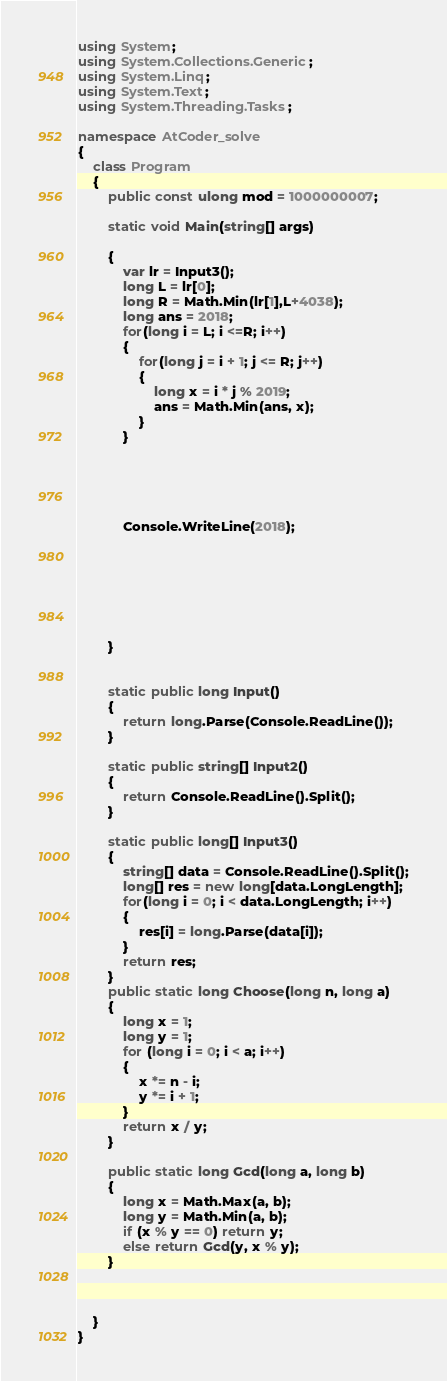Convert code to text. <code><loc_0><loc_0><loc_500><loc_500><_C#_>using System;
using System.Collections.Generic;
using System.Linq;
using System.Text;
using System.Threading.Tasks;

namespace AtCoder_solve
{
    class Program
    {
        public const ulong mod = 1000000007;

        static void Main(string[] args)

        {
            var lr = Input3();
            long L = lr[0];
            long R = Math.Min(lr[1],L+4038);
            long ans = 2018;
            for(long i = L; i <=R; i++)
            {
                for(long j = i + 1; j <= R; j++)
                {
                    long x = i * j % 2019;
                    ans = Math.Min(ans, x);
                }
            }
            
            

           
            
            Console.WriteLine(2018);
                
                





        }

       
        static public long Input()
        {
            return long.Parse(Console.ReadLine());
        }

        static public string[] Input2()
        {
            return Console.ReadLine().Split();
        }

        static public long[] Input3()
        {
            string[] data = Console.ReadLine().Split();
            long[] res = new long[data.LongLength];
            for(long i = 0; i < data.LongLength; i++)
            {
                res[i] = long.Parse(data[i]);
            }
            return res;
        }
        public static long Choose(long n, long a)
        {
            long x = 1;
            long y = 1;
            for (long i = 0; i < a; i++)
            {
                x *= n - i;
                y *= i + 1;
            }
            return x / y;
        }

        public static long Gcd(long a, long b)
        {
            long x = Math.Max(a, b);
            long y = Math.Min(a, b);
            if (x % y == 0) return y;
            else return Gcd(y, x % y);
        }

        
       
    }
}
</code> 